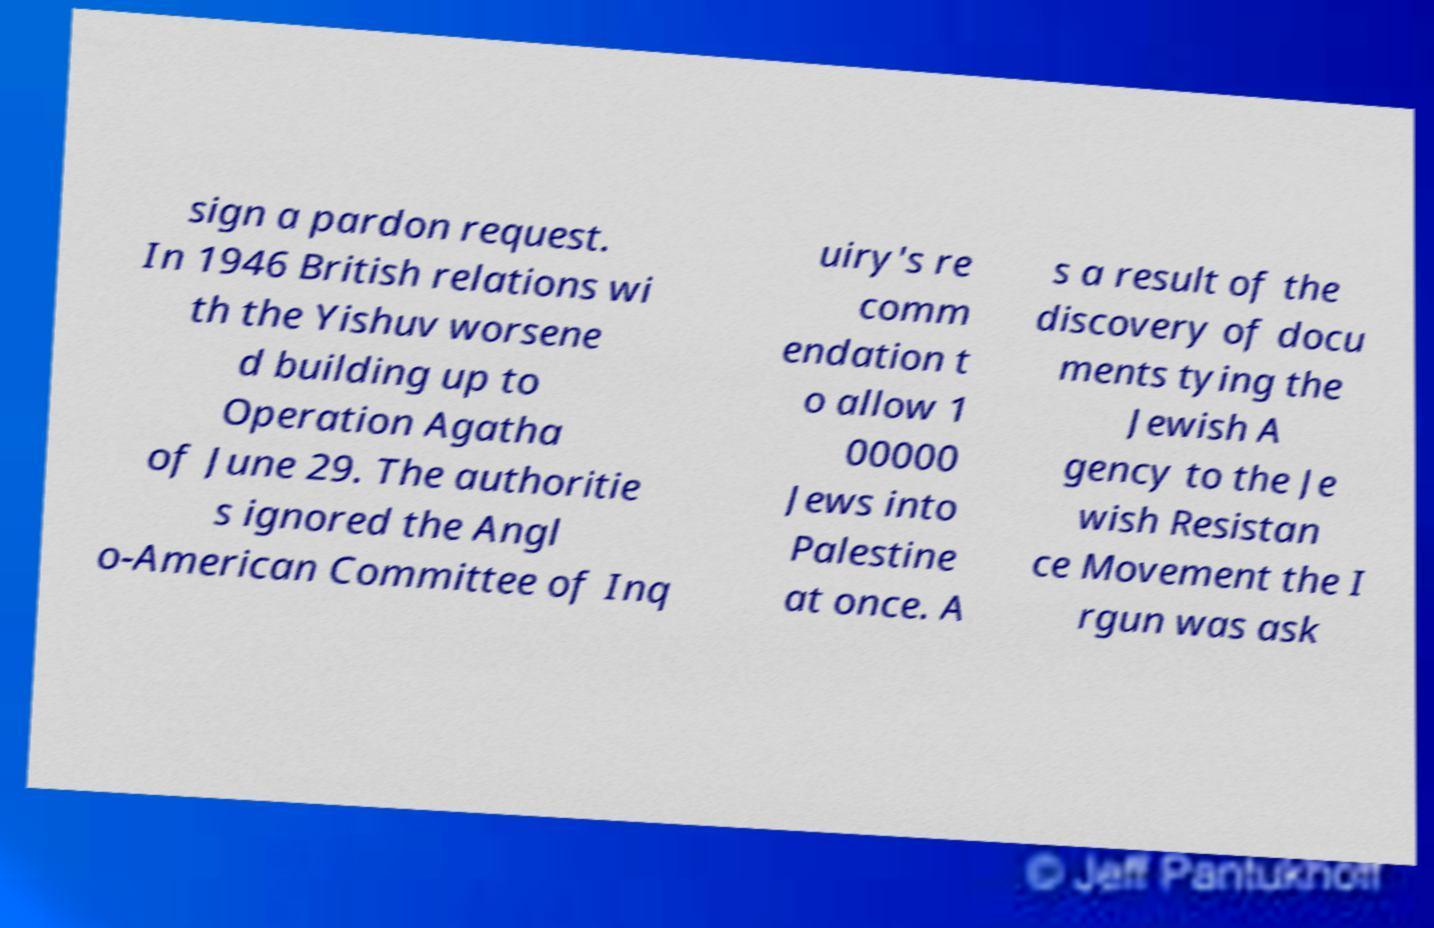Could you assist in decoding the text presented in this image and type it out clearly? sign a pardon request. In 1946 British relations wi th the Yishuv worsene d building up to Operation Agatha of June 29. The authoritie s ignored the Angl o-American Committee of Inq uiry's re comm endation t o allow 1 00000 Jews into Palestine at once. A s a result of the discovery of docu ments tying the Jewish A gency to the Je wish Resistan ce Movement the I rgun was ask 